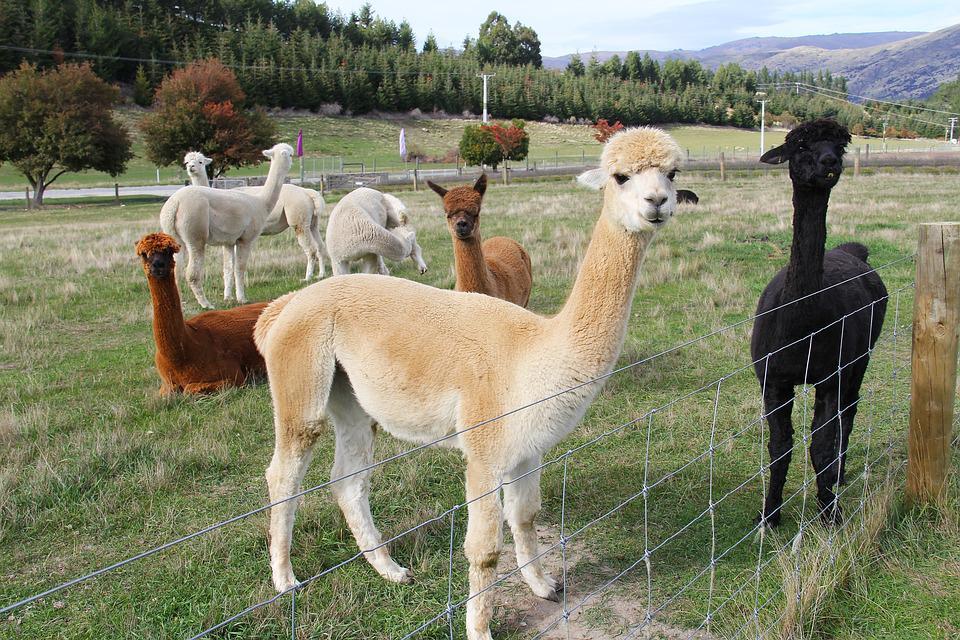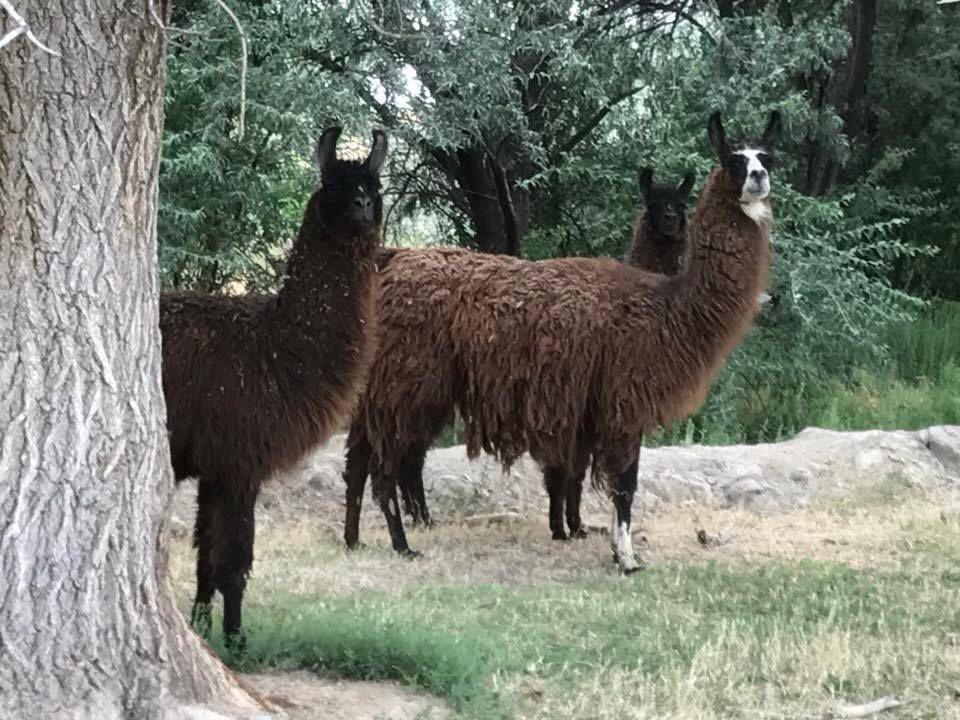The first image is the image on the left, the second image is the image on the right. Considering the images on both sides, is "One image shows one dark-eyed white llama, which faces forward and has a partly open mouth revealing several yellow teeth." valid? Answer yes or no. No. The first image is the image on the left, the second image is the image on the right. Considering the images on both sides, is "There are two llamas in total." valid? Answer yes or no. No. 